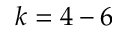Convert formula to latex. <formula><loc_0><loc_0><loc_500><loc_500>k = 4 - 6</formula> 